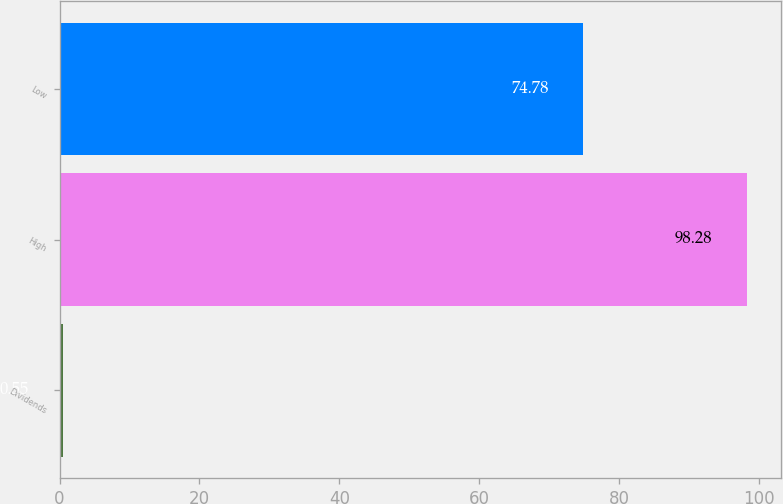<chart> <loc_0><loc_0><loc_500><loc_500><bar_chart><fcel>Dividends<fcel>High<fcel>Low<nl><fcel>0.55<fcel>98.28<fcel>74.78<nl></chart> 